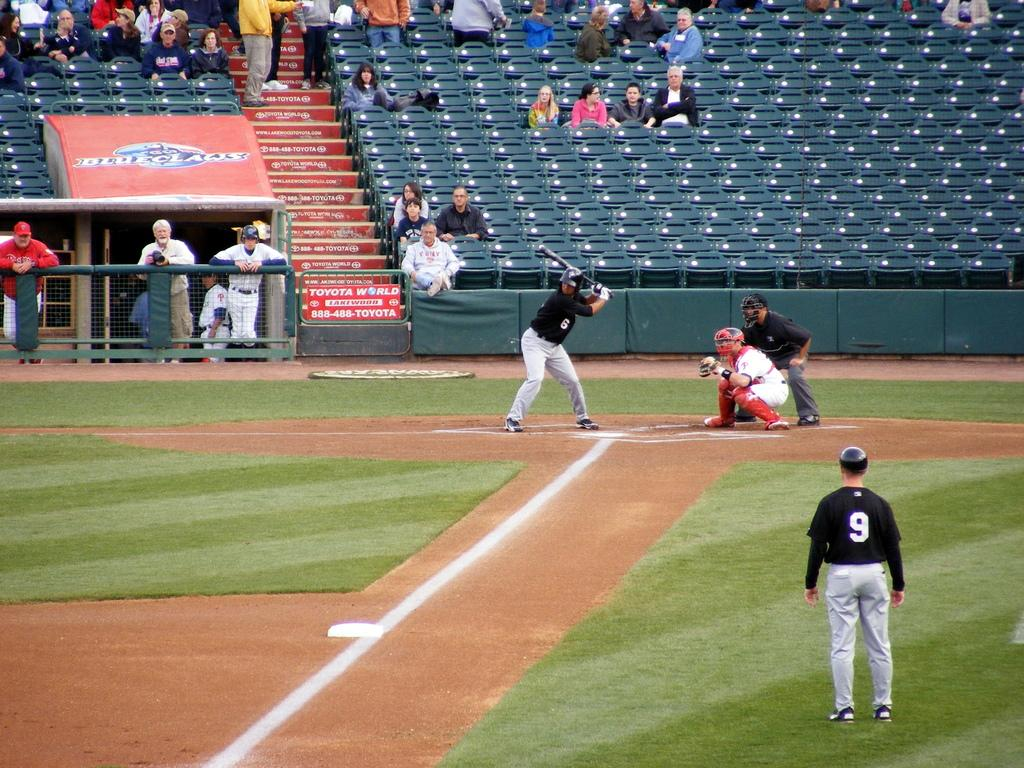<image>
Present a compact description of the photo's key features. A baseball play with 9 on his uniform stands in the field. 